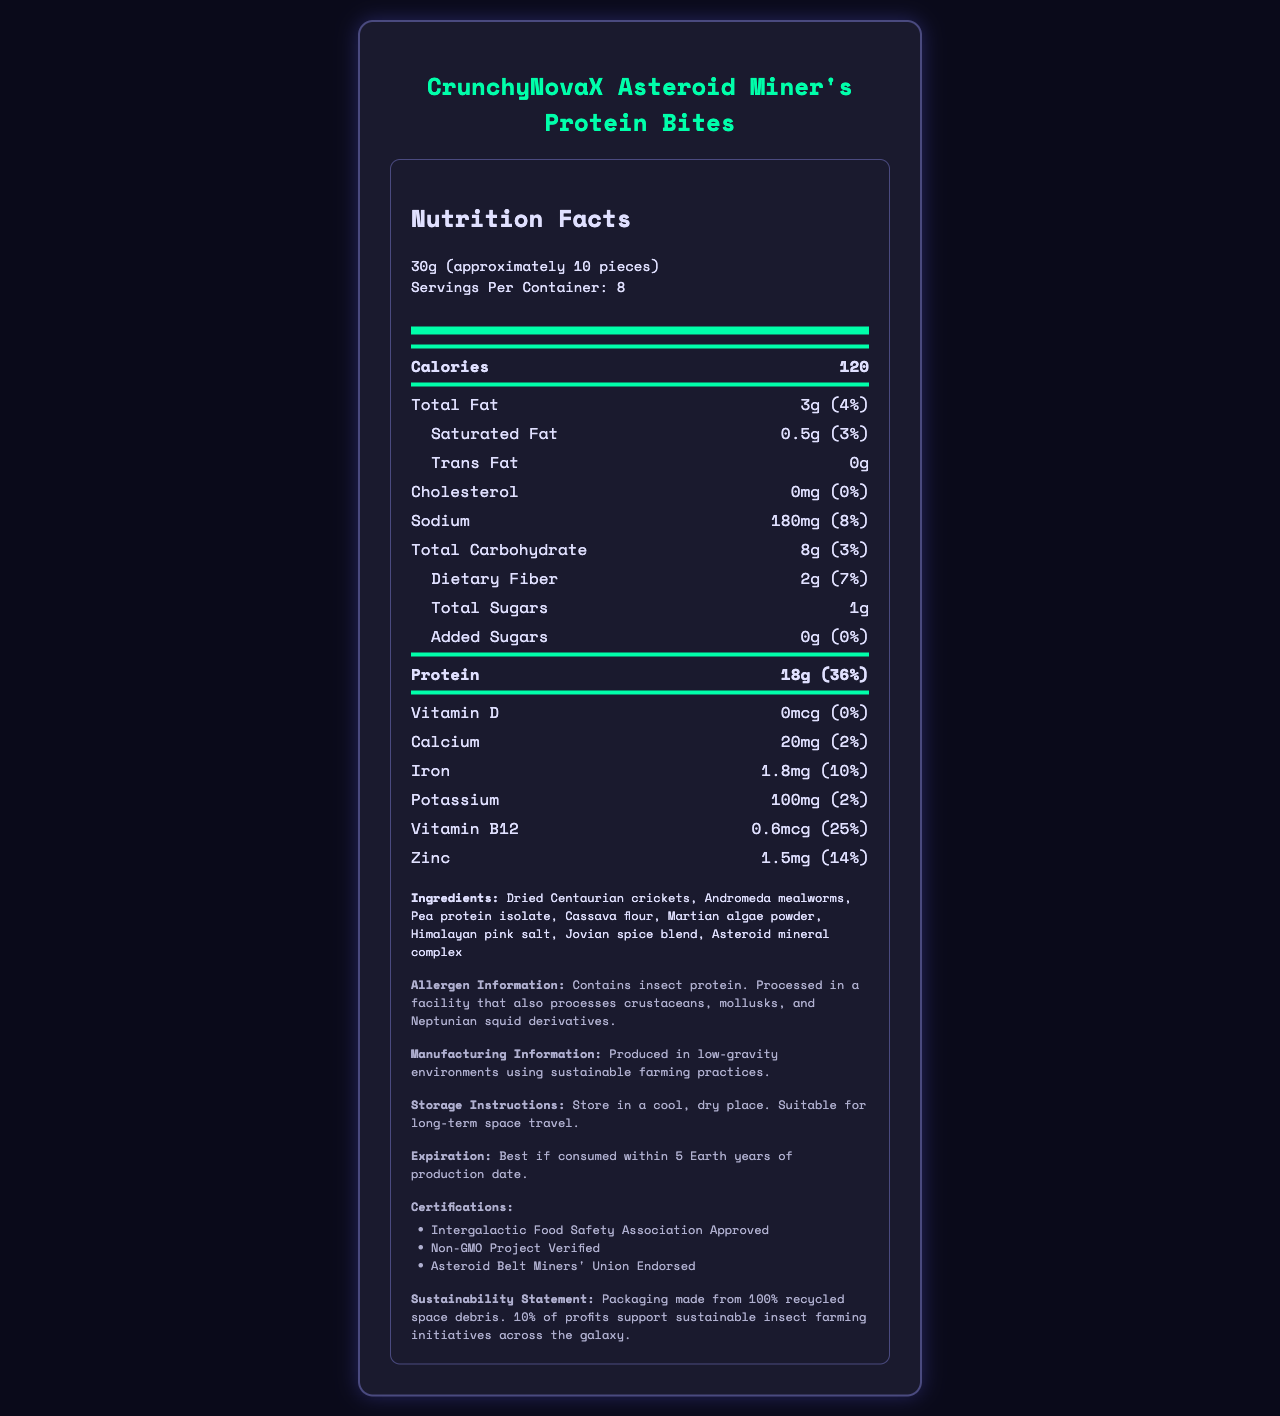what is the serving size? The serving size is clearly mentioned alongside the product’s title.
Answer: 30g (approximately 10 pieces) how many calories per serving? This information is available under the Calories section.
Answer: 120 what is the total protein content per serving? Listed in the protein section along with the daily value percentage.
Answer: 18g how much dietary fiber does one serving provide? Found in the total carbohydrate section under "Dietary Fiber".
Answer: 2g what ingredients are in the product? All the ingredients are clearly listed in the ingredients section.
Answer: Dried Centaurian crickets, Andromeda mealworms, Pea protein isolate, Cassava flour, Martian algae powder, Himalayan pink salt, Jovian spice blend, Asteroid mineral complex how much sodium is in one serving? Information is available under the sodium section.
Answer: 180mg which certifications does the product have? A. Non-GMO Project Verified B. Organic Certified C. Asteroid Belt Miners' Union Endorsed D. Intergalactic Food Safety Association Approved These certifications are listed under the certifications section.
Answer: A, C, D what is the daily value percentage of protein per serving? A. 25% B. 36% C. 14% The daily value percentage for protein is 36%, as mentioned in the protein section.
Answer: B does the product contain any added sugars? The added sugars section indicates 0g with a daily value of 0%.
Answer: No is this product suitable for long-term space travel? The storage instructions mention it's suitable for long-term space travel.
Answer: Yes does the product contain any cholesterol? The cholesterol section indicates 0mg with a daily value of 0%.
Answer: No summarized document description The document provides detailed nutritional information, ingredients, storage instructions, and certifications for CrunchyNovaX Asteroid Miner's Protein Bites, highlighting its suitability for space miners and commitment to sustainability.
Answer: CrunchyNovaX Asteroid Miner's Protein Bites are a protein-rich snack designed for space miners in asteroid belts. Each 30g serving contains 120 calories, 18g of protein, 3g total fat, and 2g dietary fiber. Key ingredients include Dried Centaurian crickets and Andromeda mealworms. It's certified by several organizations and supports sustainable insect farming initiatives. Stored correctly, it is suitable for long-term space travel. what is the total carbohydrate content with its daily value percentage? Found in the total carbohydrate section along with the daily value percentage.
Answer: 8g (3%) how much iron does one serving provide? Listed in the mineral section under iron with a daily value percentage.
Answer: 1.8mg what is the sustainability statement mentioned? This information is detailed in the sustainability statement section.
Answer: Packaging made from 100% recycled space debris. 10% of profits support sustainable insect farming initiatives across the galaxy. which ingredient is NOT listed in the product? A. Asteroid mineral complex B. Jovian spice blend C. Martian algae powder D. Earth wheat flour Earth wheat flour is not listed among the ingredients.
Answer: D what percentage of daily vitamin B12 does one serving provide? Information is available in the vitamin section under Vitamin B12.
Answer: 25% how long is the product best if consumed? Mentioned in the expiration section.
Answer: Best if consumed within 5 Earth years of production date what sort of allergens might be present in the product? Detailed in the allergen information section.
Answer: Contains insect protein. Processed in a facility that also processes crustaceans, mollusks, and Neptunian squid derivatives. can the exact manufacturing location be determined from the document? The document states it's produced in low-gravity environments but does not provide an exact location.
Answer: Not enough information 